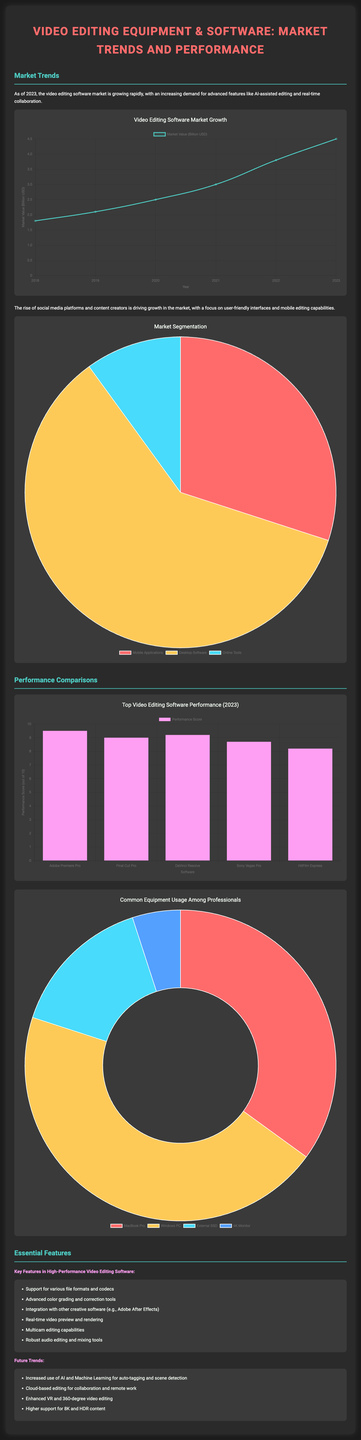What was the video editing software market value in 2023? The market value in 2023 is shown in the Market Trend Chart as 4.5 billion USD.
Answer: 4.5 billion USD Which software received the highest performance score in 2023? The software with the highest performance score in the Performance Comparisons section is Adobe Premiere Pro.
Answer: Adobe Premiere Pro What percentage of the market is represented by desktop software? The Market Segmentation Chart shows that desktop software represents 60% of the market.
Answer: 60% What is a key feature of high-performance video editing software? One key feature listed is support for various file formats and codecs.
Answer: Support for various file formats and codecs How much of the professional equipment usage is attributed to MacBook Pro? According to the Equipment Usage Chart, 35% of professionals use MacBook Pro.
Answer: 35% What trends are predicted for the future concerning video editing software? One future trend mentioned is increased use of AI and Machine Learning for auto-tagging and scene detection.
Answer: Increased use of AI and Machine Learning Which software ranks second in performance score? The Performance Comparisons Chart shows Final Cut Pro ranking second with a score of 9.0.
Answer: Final Cut Pro What year does the Market Trend Chart start showing data from? The Market Trend Chart begins showing data from the year 2018.
Answer: 2018 What is the total percentage for mobile applications as per the Market Segmentation? The Market Segmentation Chart indicates that mobile applications account for 30% of the market.
Answer: 30% 